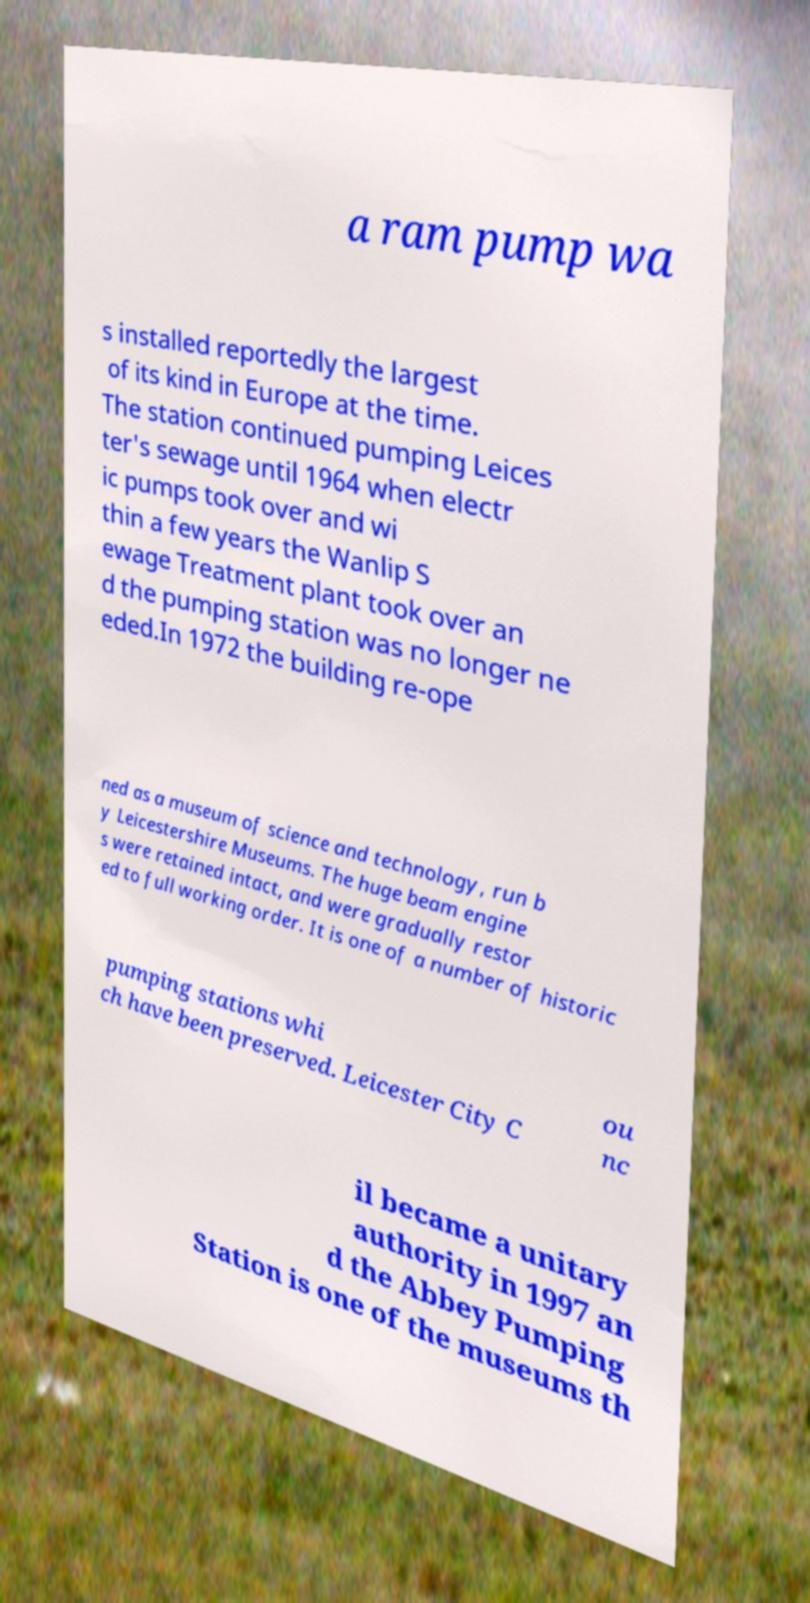I need the written content from this picture converted into text. Can you do that? a ram pump wa s installed reportedly the largest of its kind in Europe at the time. The station continued pumping Leices ter's sewage until 1964 when electr ic pumps took over and wi thin a few years the Wanlip S ewage Treatment plant took over an d the pumping station was no longer ne eded.In 1972 the building re-ope ned as a museum of science and technology, run b y Leicestershire Museums. The huge beam engine s were retained intact, and were gradually restor ed to full working order. It is one of a number of historic pumping stations whi ch have been preserved. Leicester City C ou nc il became a unitary authority in 1997 an d the Abbey Pumping Station is one of the museums th 